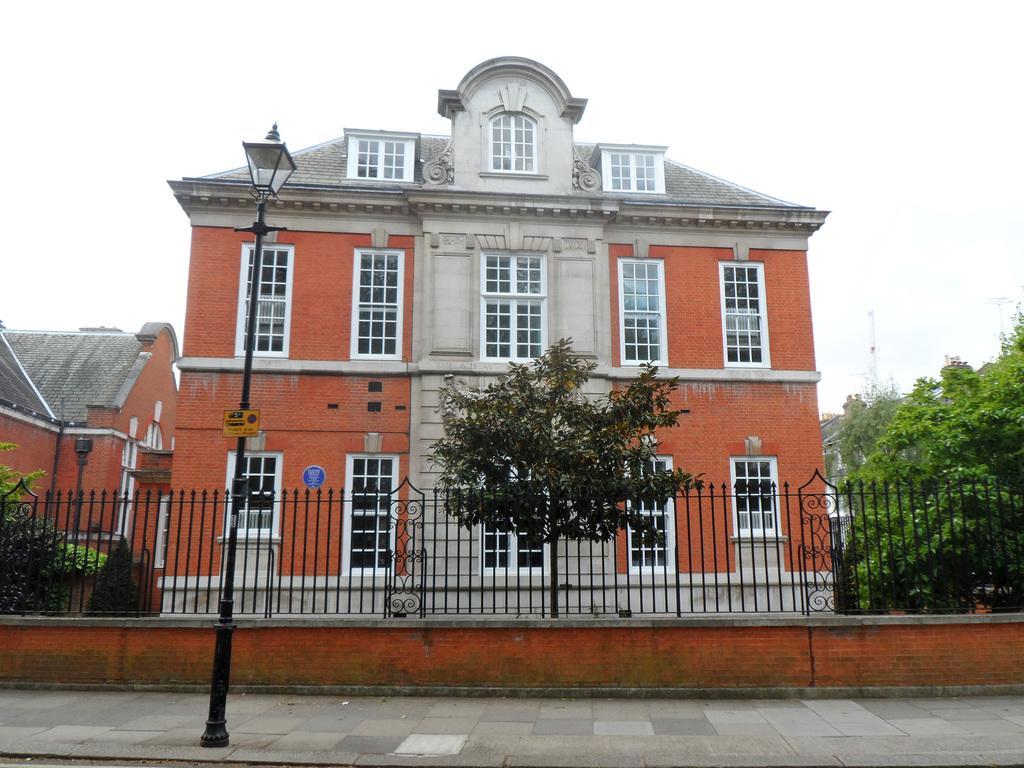In one or two sentences, can you explain what this image depicts? In this image, there is a pole on the side path on the left. Behind it, there is fencing, few trees, few buildings and the sky. 